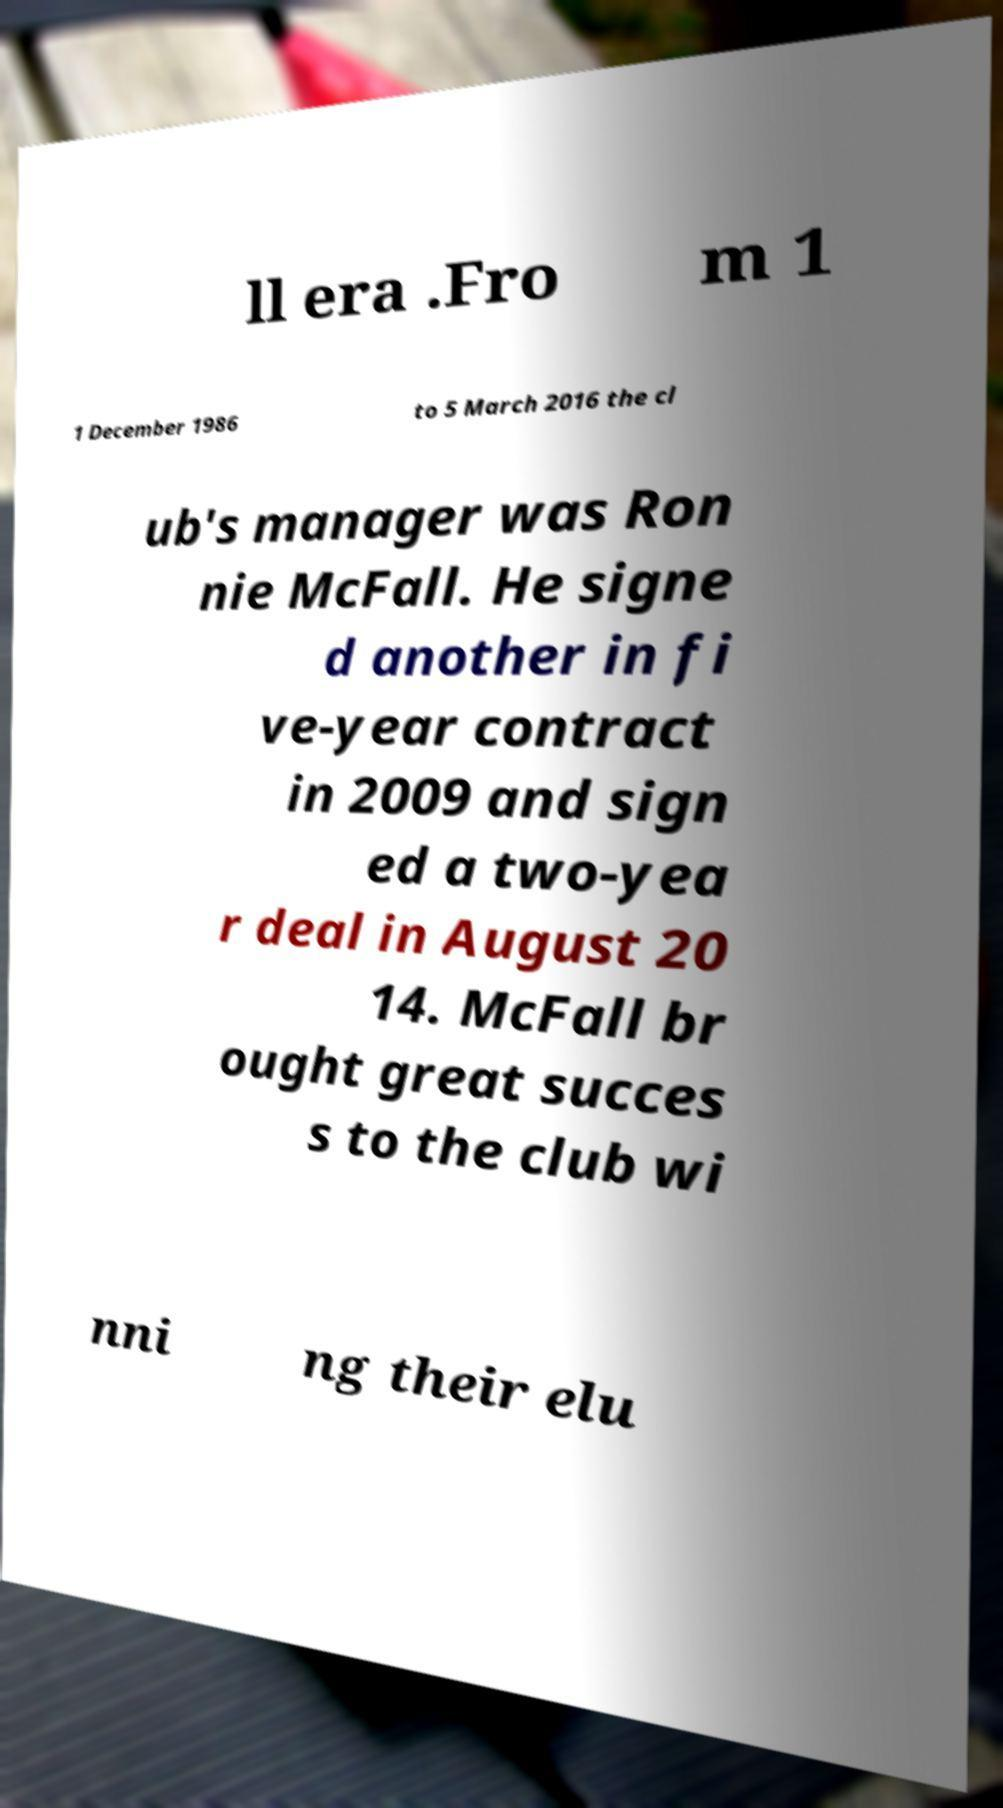Please identify and transcribe the text found in this image. ll era .Fro m 1 1 December 1986 to 5 March 2016 the cl ub's manager was Ron nie McFall. He signe d another in fi ve-year contract in 2009 and sign ed a two-yea r deal in August 20 14. McFall br ought great succes s to the club wi nni ng their elu 